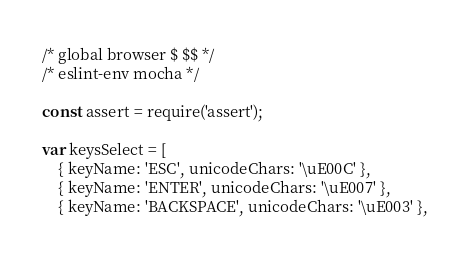<code> <loc_0><loc_0><loc_500><loc_500><_JavaScript_>/* global browser $ $$ */
/* eslint-env mocha */

const assert = require('assert');

var keysSelect = [
	{ keyName: 'ESC', unicodeChars: '\uE00C' },
	{ keyName: 'ENTER', unicodeChars: '\uE007' },
	{ keyName: 'BACKSPACE', unicodeChars: '\uE003' },</code> 